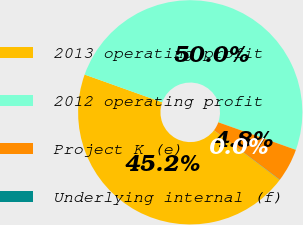Convert chart. <chart><loc_0><loc_0><loc_500><loc_500><pie_chart><fcel>2013 operating profit<fcel>2012 operating profit<fcel>Project K (e)<fcel>Underlying internal (f)<nl><fcel>45.17%<fcel>49.97%<fcel>4.83%<fcel>0.03%<nl></chart> 